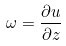Convert formula to latex. <formula><loc_0><loc_0><loc_500><loc_500>\omega = \frac { \partial u } { \partial z }</formula> 